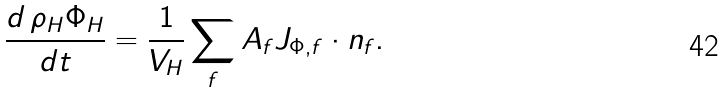Convert formula to latex. <formula><loc_0><loc_0><loc_500><loc_500>\frac { d \, \rho _ { H } \Phi _ { H } } { d t } = \frac { 1 } { V _ { H } } \sum _ { f } A _ { f } J _ { \Phi , f } \cdot n _ { f } .</formula> 